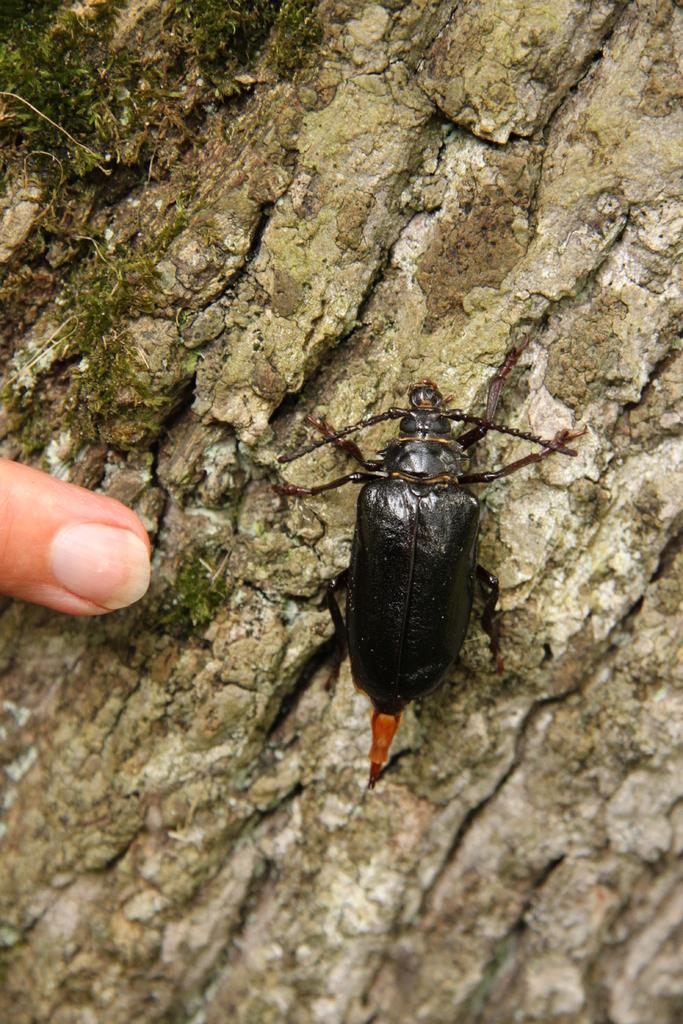What type of creature can be seen in the image? There is an insect in the image. What type of love can be seen between the goldfish in the image? There are no goldfish present in the image, and therefore no love can be observed between them. 